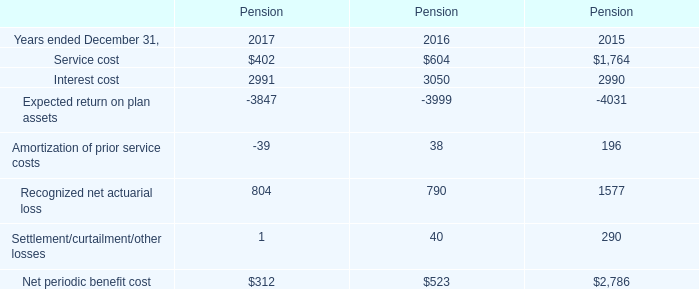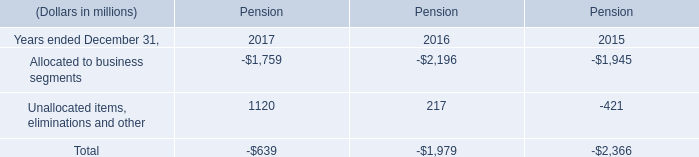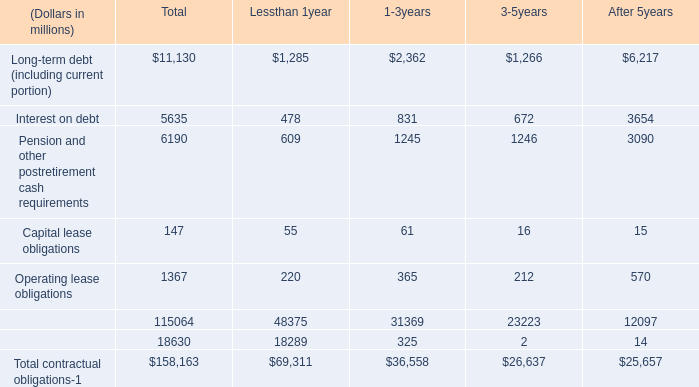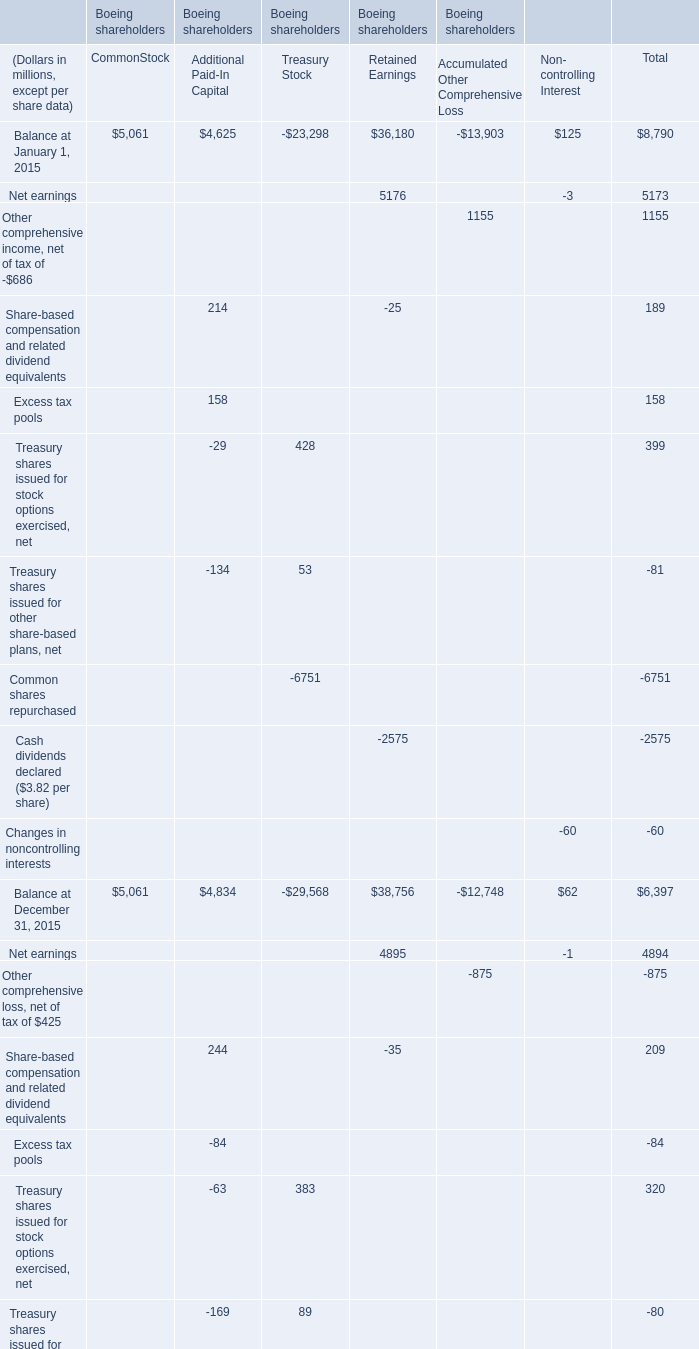What is the average amount of Balance at December 31, 2017 of Boeing shareholders CommonStock, and Interest cost of Pension 2017 ? 
Computations: ((5061.0 + 2991.0) / 2)
Answer: 4026.0. 